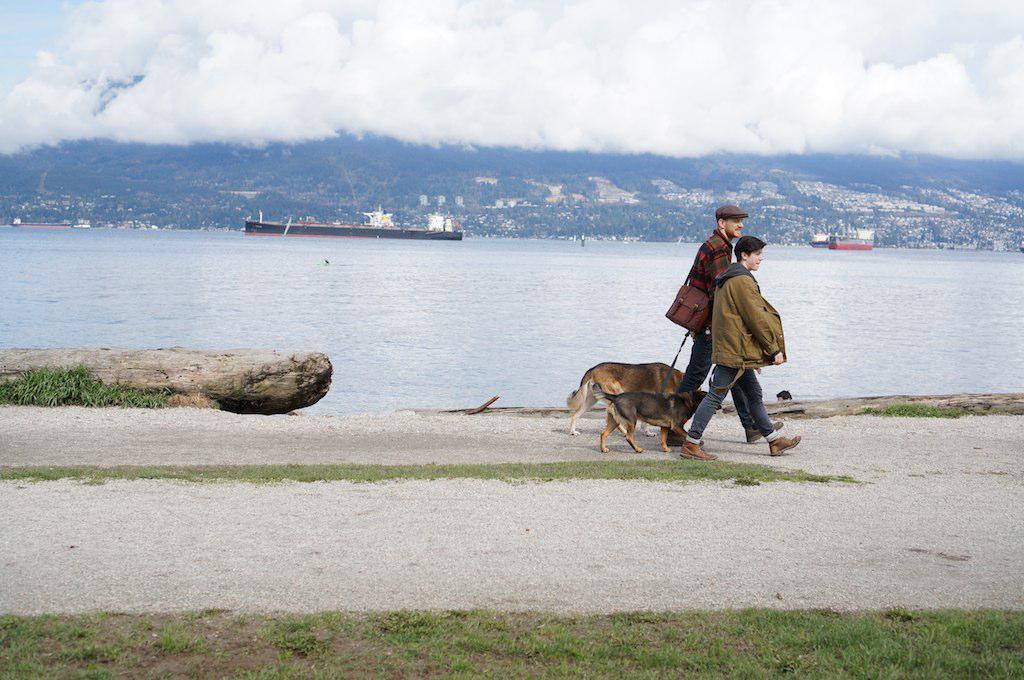Could you give a brief overview of what you see in this image? The two persons walking and holding a belt which is tightened to the dogs and there is a mountain,river and ships beside them and the sky is cloudy. 